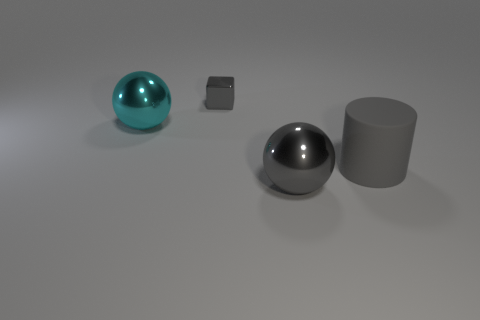Add 1 large matte things. How many objects exist? 5 Subtract all blocks. How many objects are left? 3 Add 3 gray shiny cubes. How many gray shiny cubes exist? 4 Subtract 0 yellow blocks. How many objects are left? 4 Subtract all gray objects. Subtract all tiny blue matte objects. How many objects are left? 1 Add 4 big gray cylinders. How many big gray cylinders are left? 5 